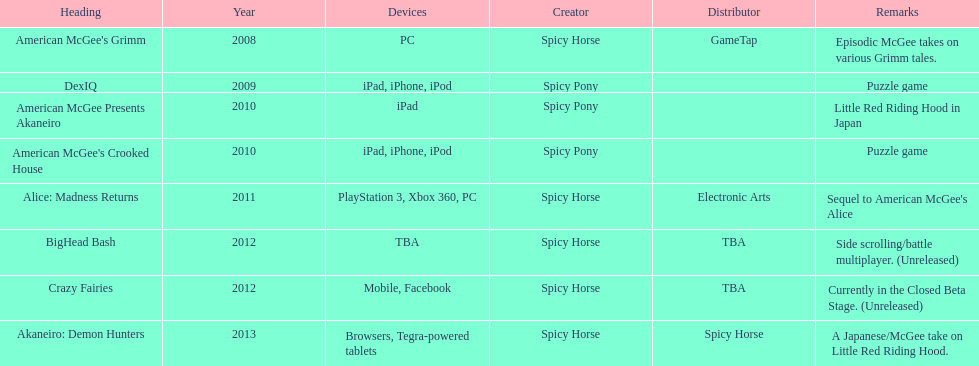What was the only game published by electronic arts? Alice: Madness Returns. 